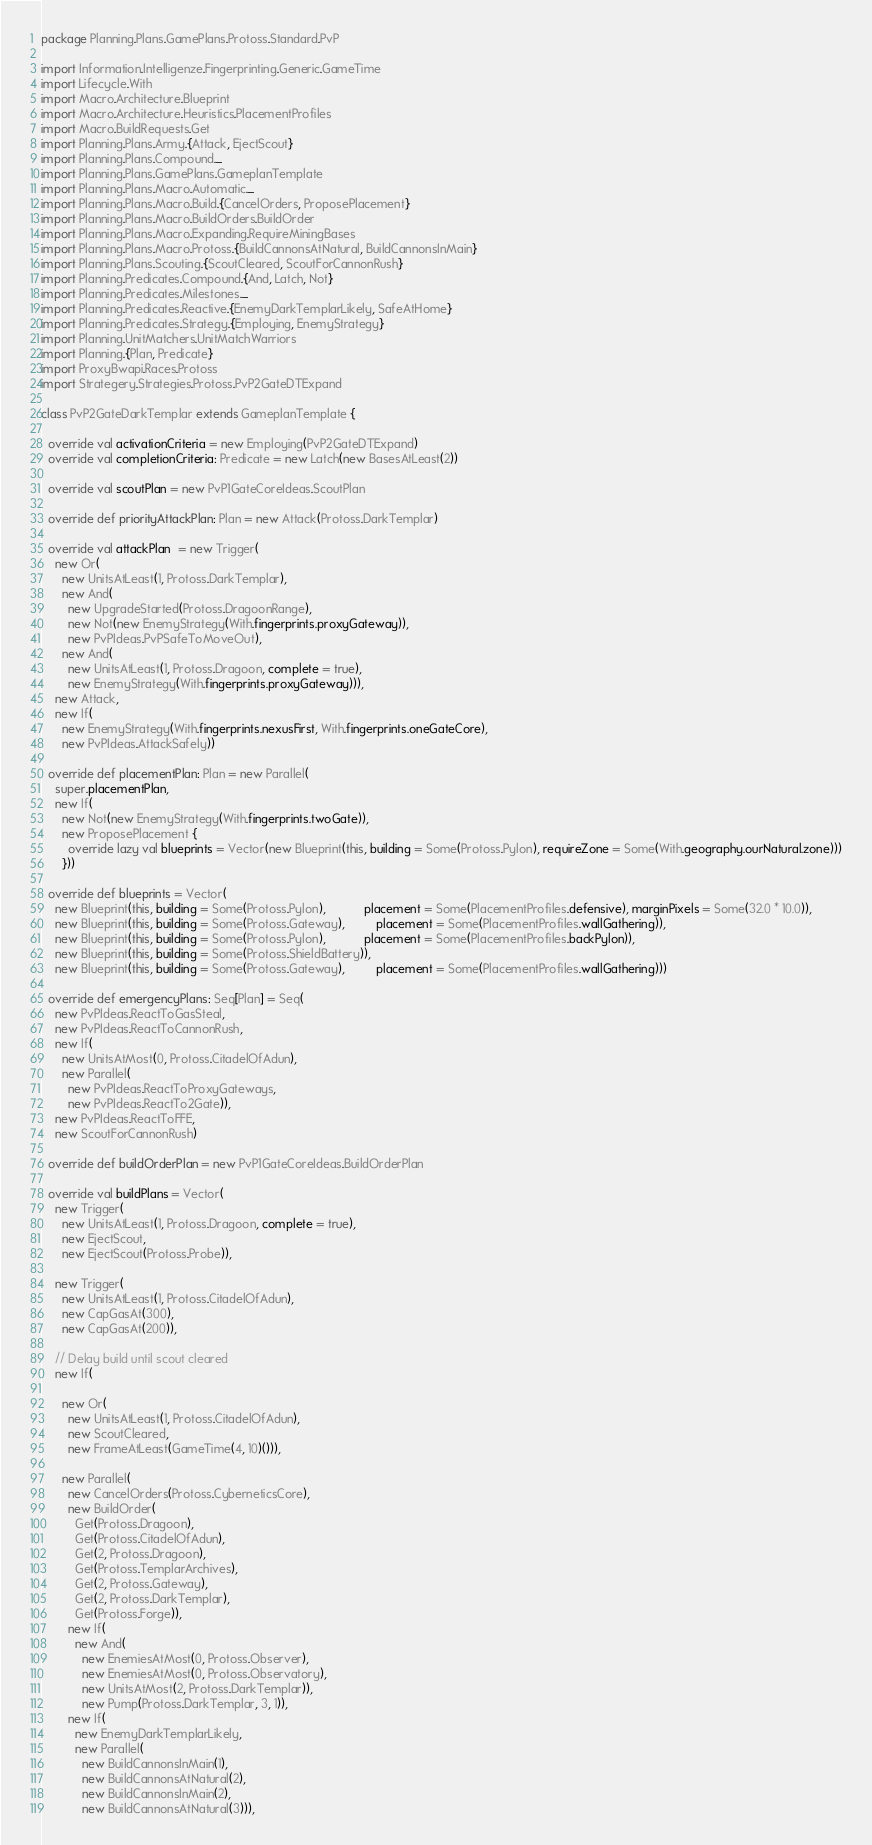Convert code to text. <code><loc_0><loc_0><loc_500><loc_500><_Scala_>package Planning.Plans.GamePlans.Protoss.Standard.PvP

import Information.Intelligenze.Fingerprinting.Generic.GameTime
import Lifecycle.With
import Macro.Architecture.Blueprint
import Macro.Architecture.Heuristics.PlacementProfiles
import Macro.BuildRequests.Get
import Planning.Plans.Army.{Attack, EjectScout}
import Planning.Plans.Compound._
import Planning.Plans.GamePlans.GameplanTemplate
import Planning.Plans.Macro.Automatic._
import Planning.Plans.Macro.Build.{CancelOrders, ProposePlacement}
import Planning.Plans.Macro.BuildOrders.BuildOrder
import Planning.Plans.Macro.Expanding.RequireMiningBases
import Planning.Plans.Macro.Protoss.{BuildCannonsAtNatural, BuildCannonsInMain}
import Planning.Plans.Scouting.{ScoutCleared, ScoutForCannonRush}
import Planning.Predicates.Compound.{And, Latch, Not}
import Planning.Predicates.Milestones._
import Planning.Predicates.Reactive.{EnemyDarkTemplarLikely, SafeAtHome}
import Planning.Predicates.Strategy.{Employing, EnemyStrategy}
import Planning.UnitMatchers.UnitMatchWarriors
import Planning.{Plan, Predicate}
import ProxyBwapi.Races.Protoss
import Strategery.Strategies.Protoss.PvP2GateDTExpand

class PvP2GateDarkTemplar extends GameplanTemplate {
  
  override val activationCriteria = new Employing(PvP2GateDTExpand)
  override val completionCriteria: Predicate = new Latch(new BasesAtLeast(2))

  override val scoutPlan = new PvP1GateCoreIdeas.ScoutPlan

  override def priorityAttackPlan: Plan = new Attack(Protoss.DarkTemplar)

  override val attackPlan  = new Trigger(
    new Or(
      new UnitsAtLeast(1, Protoss.DarkTemplar),
      new And(
        new UpgradeStarted(Protoss.DragoonRange),
        new Not(new EnemyStrategy(With.fingerprints.proxyGateway)),
        new PvPIdeas.PvPSafeToMoveOut),
      new And(
        new UnitsAtLeast(1, Protoss.Dragoon, complete = true),
        new EnemyStrategy(With.fingerprints.proxyGateway))),
    new Attack,
    new If(
      new EnemyStrategy(With.fingerprints.nexusFirst, With.fingerprints.oneGateCore),
      new PvPIdeas.AttackSafely))

  override def placementPlan: Plan = new Parallel(
    super.placementPlan,
    new If(
      new Not(new EnemyStrategy(With.fingerprints.twoGate)),
      new ProposePlacement {
        override lazy val blueprints = Vector(new Blueprint(this, building = Some(Protoss.Pylon), requireZone = Some(With.geography.ourNatural.zone)))
      }))

  override def blueprints = Vector(
    new Blueprint(this, building = Some(Protoss.Pylon),           placement = Some(PlacementProfiles.defensive), marginPixels = Some(32.0 * 10.0)),
    new Blueprint(this, building = Some(Protoss.Gateway),         placement = Some(PlacementProfiles.wallGathering)),
    new Blueprint(this, building = Some(Protoss.Pylon),           placement = Some(PlacementProfiles.backPylon)),
    new Blueprint(this, building = Some(Protoss.ShieldBattery)),
    new Blueprint(this, building = Some(Protoss.Gateway),         placement = Some(PlacementProfiles.wallGathering)))

  override def emergencyPlans: Seq[Plan] = Seq(
    new PvPIdeas.ReactToGasSteal,
    new PvPIdeas.ReactToCannonRush,
    new If(
      new UnitsAtMost(0, Protoss.CitadelOfAdun),
      new Parallel(
        new PvPIdeas.ReactToProxyGateways,
        new PvPIdeas.ReactTo2Gate)),
    new PvPIdeas.ReactToFFE,
    new ScoutForCannonRush)

  override def buildOrderPlan = new PvP1GateCoreIdeas.BuildOrderPlan
  
  override val buildPlans = Vector(
    new Trigger(
      new UnitsAtLeast(1, Protoss.Dragoon, complete = true),
      new EjectScout,
      new EjectScout(Protoss.Probe)),

    new Trigger(
      new UnitsAtLeast(1, Protoss.CitadelOfAdun),
      new CapGasAt(300),
      new CapGasAt(200)),

    // Delay build until scout cleared
    new If(

      new Or(
        new UnitsAtLeast(1, Protoss.CitadelOfAdun),
        new ScoutCleared,
        new FrameAtLeast(GameTime(4, 10)())),

      new Parallel(
        new CancelOrders(Protoss.CyberneticsCore),
        new BuildOrder(
          Get(Protoss.Dragoon),
          Get(Protoss.CitadelOfAdun),
          Get(2, Protoss.Dragoon),
          Get(Protoss.TemplarArchives),
          Get(2, Protoss.Gateway),
          Get(2, Protoss.DarkTemplar),
          Get(Protoss.Forge)),
        new If(
          new And(
            new EnemiesAtMost(0, Protoss.Observer),
            new EnemiesAtMost(0, Protoss.Observatory),
            new UnitsAtMost(2, Protoss.DarkTemplar)),
            new Pump(Protoss.DarkTemplar, 3, 1)),
        new If(
          new EnemyDarkTemplarLikely,
          new Parallel(
            new BuildCannonsInMain(1),
            new BuildCannonsAtNatural(2),
            new BuildCannonsInMain(2),
            new BuildCannonsAtNatural(3))),</code> 